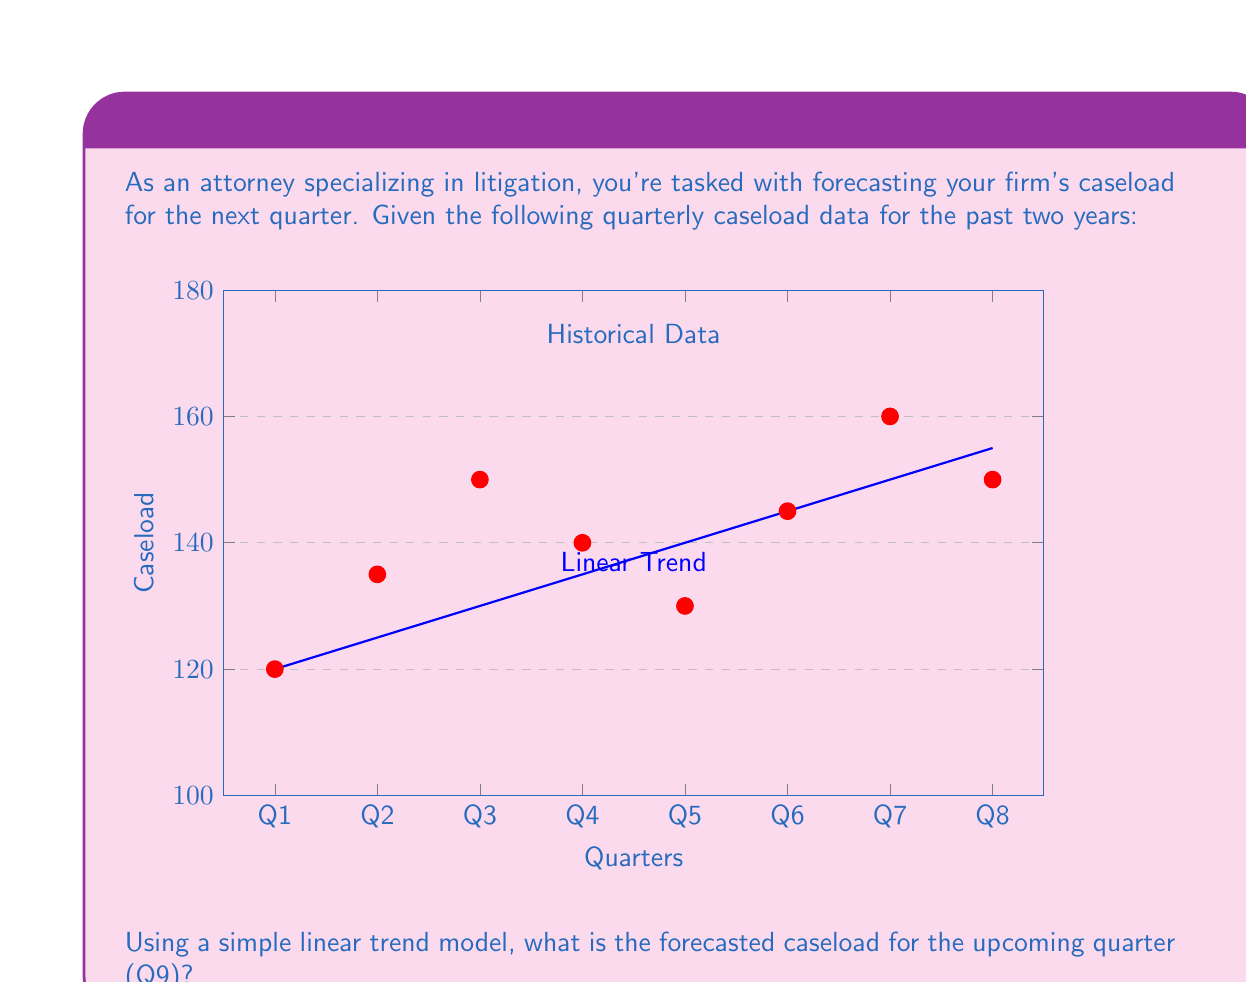Could you help me with this problem? To forecast the caseload using a simple linear trend model, we'll follow these steps:

1) First, we need to find the linear equation in the form $y = mx + b$, where:
   $y$ is the caseload
   $x$ is the quarter number
   $m$ is the slope (average increase per quarter)
   $b$ is the y-intercept (initial caseload)

2) To find $m$, we'll use the first and last data points:
   $m = \frac{y_8 - y_1}{x_8 - x_1} = \frac{150 - 120}{7 - 0} = \frac{30}{7} \approx 4.29$

3) To find $b$, we can use either the first or last point. Let's use the first:
   $120 = m(0) + b$
   $b = 120$

4) Our linear equation is thus: $y = 4.29x + 120$

5) To forecast Q9, we substitute $x = 8$ (as Q9 is the 9th quarter, indexed from 0):
   $y = 4.29(8) + 120 = 34.32 + 120 = 154.32$

6) Rounding to the nearest whole number (as we can't have fractional cases), our forecast is 154 cases.
Answer: 154 cases 